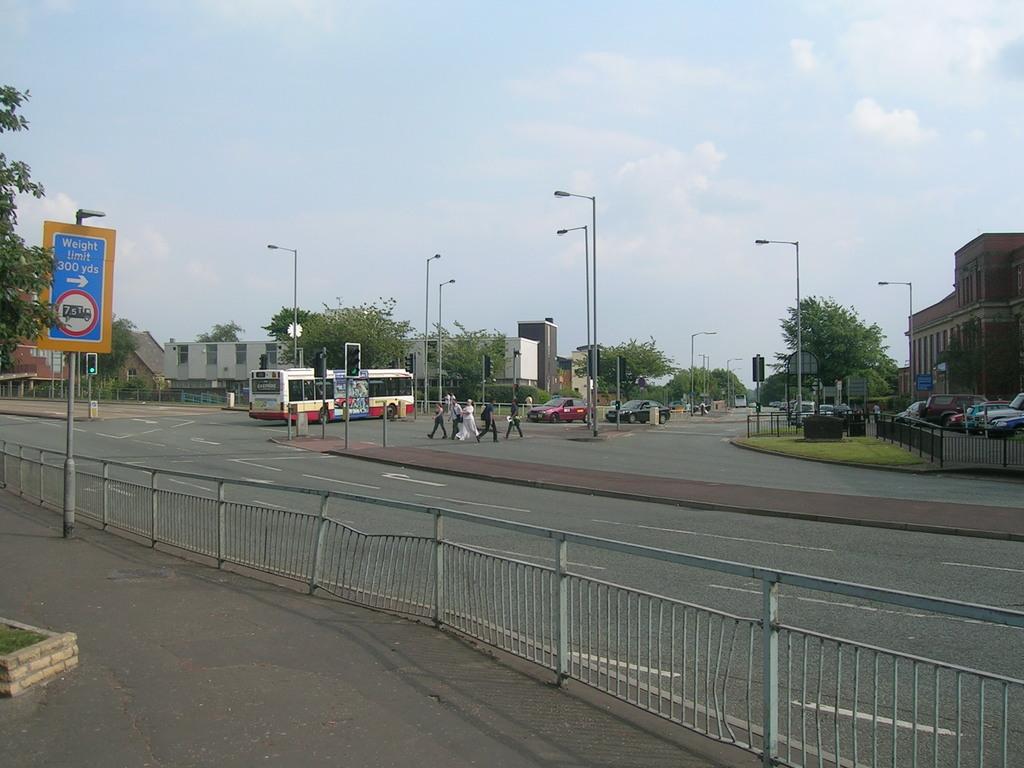What type of limit does the sign say?
Offer a terse response. Weight. In what direction is the sign showing you to go?
Offer a very short reply. Right. 